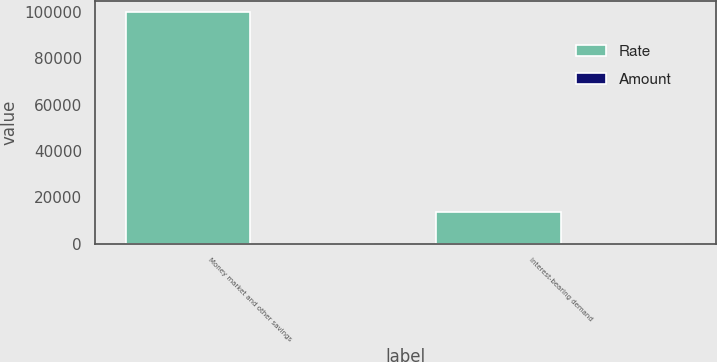<chart> <loc_0><loc_0><loc_500><loc_500><stacked_bar_chart><ecel><fcel>Money market and other savings<fcel>Interest-bearing demand<nl><fcel>Rate<fcel>99881<fcel>13583<nl><fcel>Amount<fcel>0.02<fcel>0.07<nl></chart> 